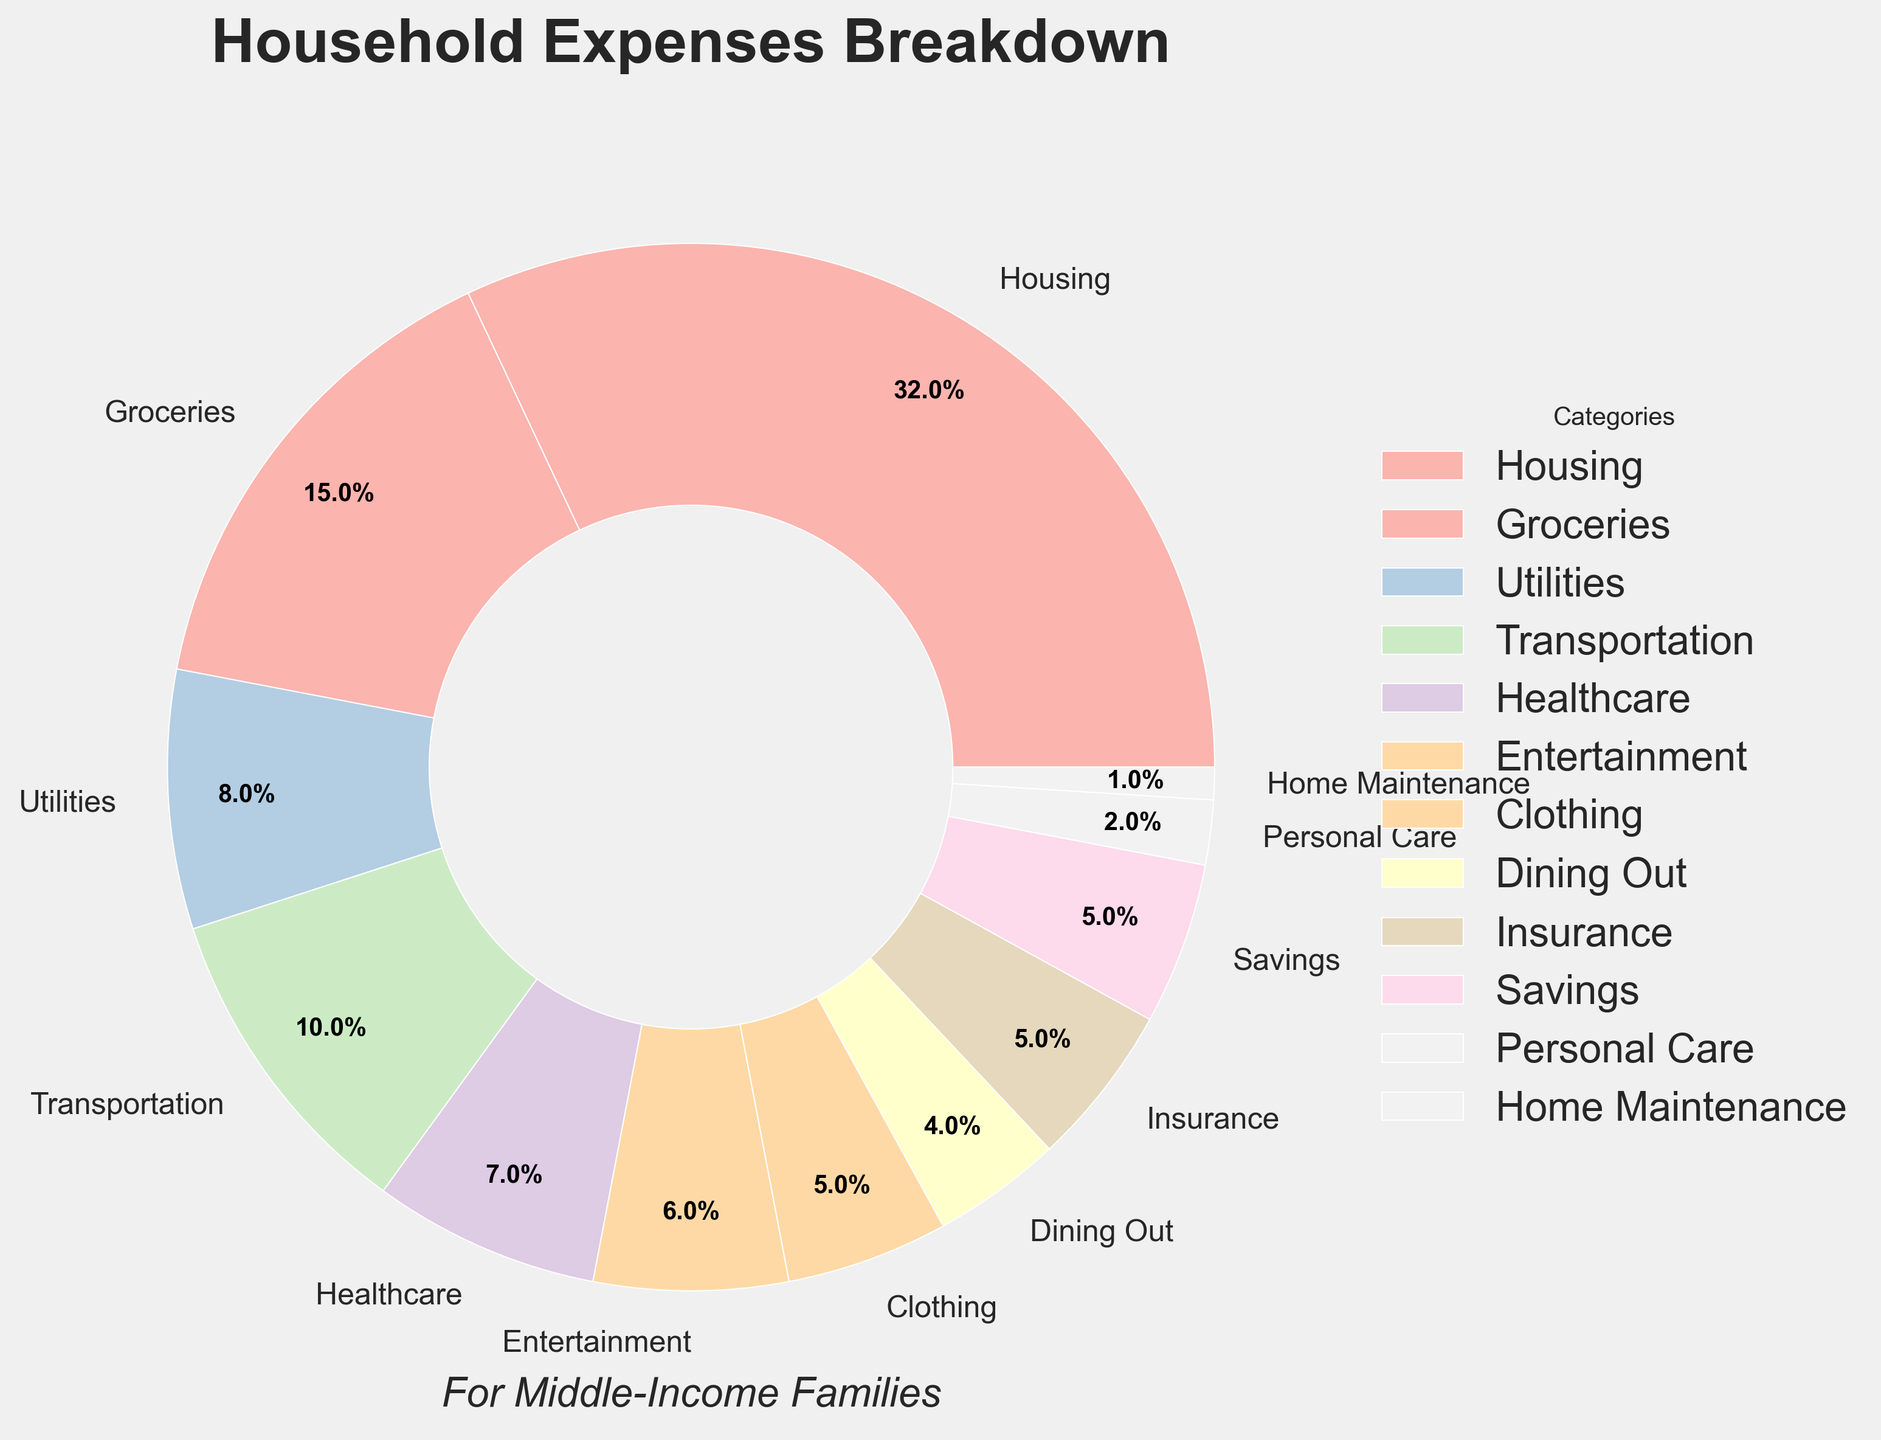Which category has the highest percentage? The category with the highest percentage is identified by the largest portion of the pie chart. Housing has the highest percentage at 32%.
Answer: Housing Which category has the lowest percentage? The category with the lowest percentage is identified by the smallest portion of the pie chart. Home Maintenance has the lowest percentage at 1%.
Answer: Home Maintenance How much more is spent on Housing compared to Groceries? The percentage spent on Housing is 32% and on Groceries is 15%. The difference is 32% - 15% = 17%.
Answer: 17% What is the combined percentage for Entertainment and Dining Out? The percentage for Entertainment is 6% and for Dining Out is 4%. The combined percentage is 6% + 4% = 10%.
Answer: 10% Which category's slice is visually represented with the second-largest portion? The second-largest portion can be identified by comparing the sizes of all slices. Groceries, at 15%, is the second-largest.
Answer: Groceries Is the percentage spent on Clothing greater than that on Healthcare? The percentage for Clothing is 5% and for Healthcare is 7%. Clothing is not greater than Healthcare.
Answer: No How does the percentage spent on Transportation compare to that of Utilities? The percentages for Transportation and Utilities are 10% and 8%, respectively. Transportation is 2% greater than Utilities.
Answer: 2% greater What is the combined percentage of Savings, Insurance, and Personal Care? The percentages for Savings, Insurance, and Personal Care are 5%, 5%, and 2%, respectively. The combined percentage is 5% + 5% + 2% = 12%.
Answer: 12% Which three categories have the smallest percentages and what are their combined total? The three smallest categories are Home Maintenance (1%), Personal Care (2%), and Dining Out (4%). Their combined total is 1% + 2% + 4% = 7%.
Answer: 7% How much more is spent on Housing than on Transportation, Utilities, and Healthcare combined? Housing is 32%. The combined percentage for Transportation (10%), Utilities (8%), and Healthcare (7%) is 10% + 8% + 7% = 25%. The difference is 32% - 25% = 7%.
Answer: 7% 